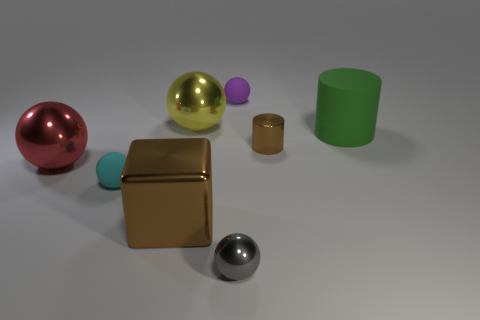What color is the other rubber object that is the same shape as the purple matte thing?
Provide a short and direct response. Cyan. How many tiny metallic balls have the same color as the metal cube?
Your answer should be very brief. 0. What is the color of the small matte ball that is right of the tiny shiny thing in front of the big ball that is in front of the green object?
Keep it short and to the point. Purple. Does the large red object have the same material as the small brown cylinder?
Your response must be concise. Yes. Is the red metal object the same shape as the cyan matte thing?
Provide a succinct answer. Yes. Is the number of tiny brown cylinders in front of the green rubber thing the same as the number of tiny shiny things that are behind the shiny cylinder?
Your response must be concise. No. The big cube that is made of the same material as the tiny brown cylinder is what color?
Keep it short and to the point. Brown. How many big red cylinders are the same material as the small gray object?
Your answer should be compact. 0. There is a small object behind the big green matte thing; is its color the same as the small cylinder?
Make the answer very short. No. What number of big rubber objects are the same shape as the small brown metallic thing?
Make the answer very short. 1. 